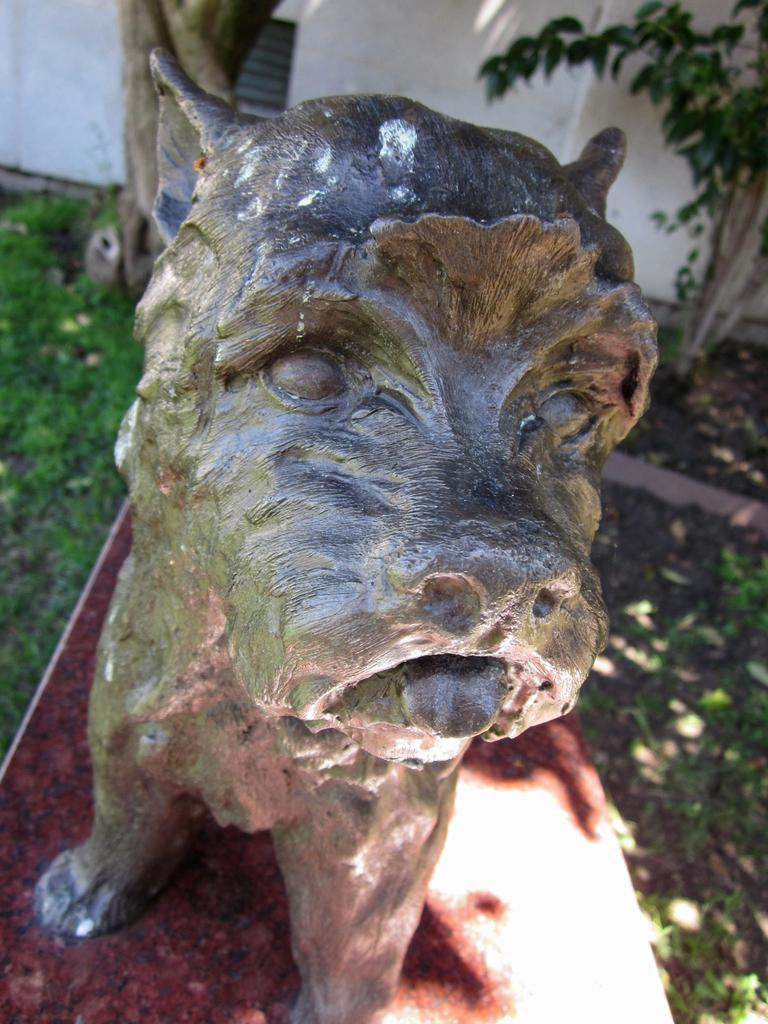What is the main subject of the image? The main subject of the image is a dog statue. Where is the dog statue located? The dog statue is on the ground. What type of vegetation is on the left side of the image? There is grass on the left side of the image. What can be seen in the top right corner of the image? There is a plant in the top right corner of the image. What is the relationship between the plant and the wall? The plant is near a wall. Is the dog statue driving a car in the image? No, the dog statue is not driving a car in the image; it is a stationary statue on the ground. 